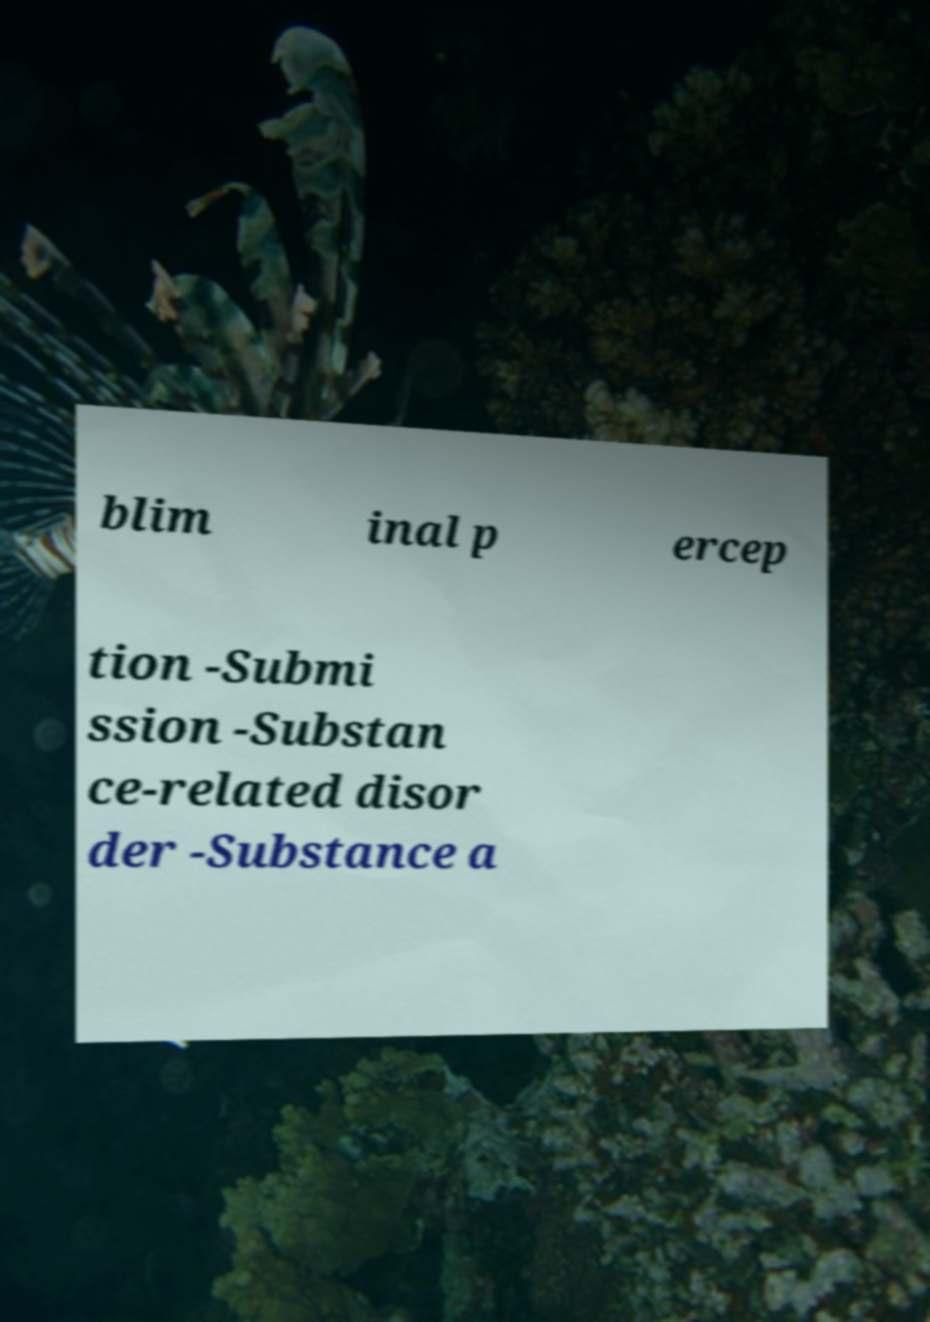What messages or text are displayed in this image? I need them in a readable, typed format. blim inal p ercep tion -Submi ssion -Substan ce-related disor der -Substance a 